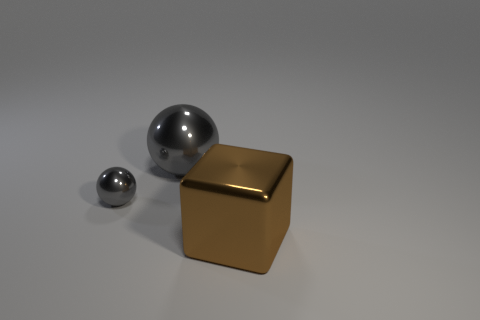Add 3 cubes. How many objects exist? 6 Subtract all cubes. How many objects are left? 2 Subtract all small gray shiny balls. Subtract all gray things. How many objects are left? 0 Add 3 gray metal things. How many gray metal things are left? 5 Add 3 gray metallic cylinders. How many gray metallic cylinders exist? 3 Subtract 0 brown balls. How many objects are left? 3 